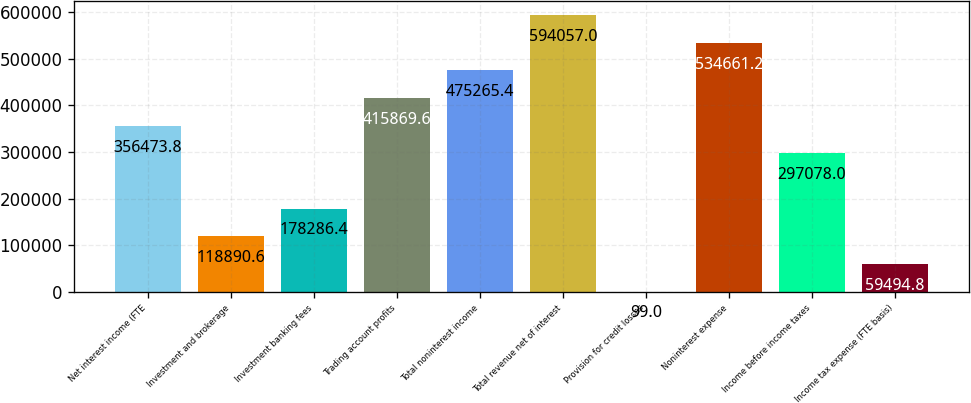Convert chart. <chart><loc_0><loc_0><loc_500><loc_500><bar_chart><fcel>Net interest income (FTE<fcel>Investment and brokerage<fcel>Investment banking fees<fcel>Trading account profits<fcel>Total noninterest income<fcel>Total revenue net of interest<fcel>Provision for credit losses<fcel>Noninterest expense<fcel>Income before income taxes<fcel>Income tax expense (FTE basis)<nl><fcel>356474<fcel>118891<fcel>178286<fcel>415870<fcel>475265<fcel>594057<fcel>99<fcel>534661<fcel>297078<fcel>59494.8<nl></chart> 